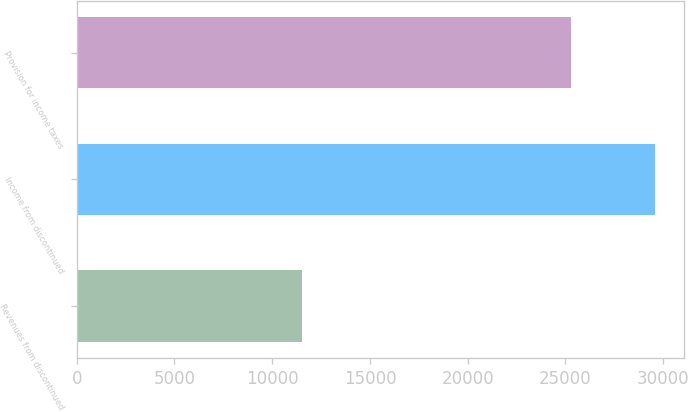Convert chart to OTSL. <chart><loc_0><loc_0><loc_500><loc_500><bar_chart><fcel>Revenues from discontinued<fcel>Income from discontinued<fcel>Provision for income taxes<nl><fcel>11512<fcel>29602<fcel>25305<nl></chart> 